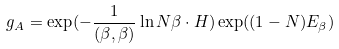<formula> <loc_0><loc_0><loc_500><loc_500>g _ { A } = \exp ( - { \frac { 1 } { ( \beta , \beta ) } \ln N } \beta \cdot H ) \exp ( ( 1 - N ) E _ { \beta } )</formula> 